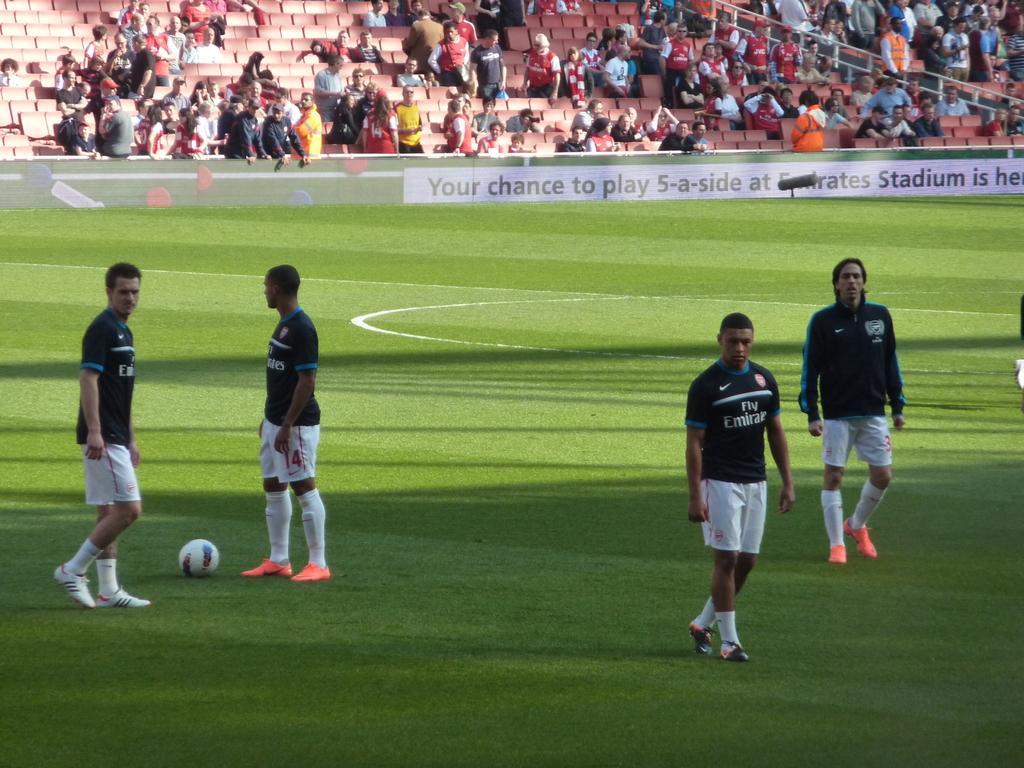In one or two sentences, can you explain what this image depicts? In this picture we can see there are three people walking and a man is standing and on the path there is a ball. Behind the people there are boards and groups of people standing and some people sitting on chairs. On the right side of the people there is iron fence. 